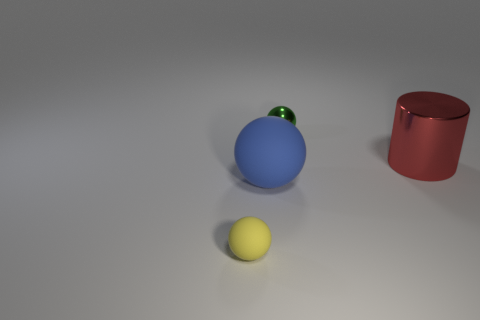Are there any other big red spheres that have the same material as the big ball?
Make the answer very short. No. What number of balls are big blue matte objects or green shiny objects?
Provide a short and direct response. 2. There is a rubber sphere that is to the left of the big blue matte sphere; are there any tiny yellow rubber spheres that are behind it?
Offer a very short reply. No. Is the number of red things less than the number of big purple metal cylinders?
Offer a very short reply. No. What number of green metal objects have the same shape as the small yellow matte object?
Provide a short and direct response. 1. How many gray objects are either tiny metal things or metallic cylinders?
Offer a very short reply. 0. What size is the red metallic thing right of the big blue matte sphere to the left of the large red shiny cylinder?
Ensure brevity in your answer.  Large. There is another large thing that is the same shape as the green object; what material is it?
Provide a short and direct response. Rubber. What number of green objects are the same size as the blue rubber sphere?
Provide a succinct answer. 0. Is the green ball the same size as the red shiny cylinder?
Offer a very short reply. No. 